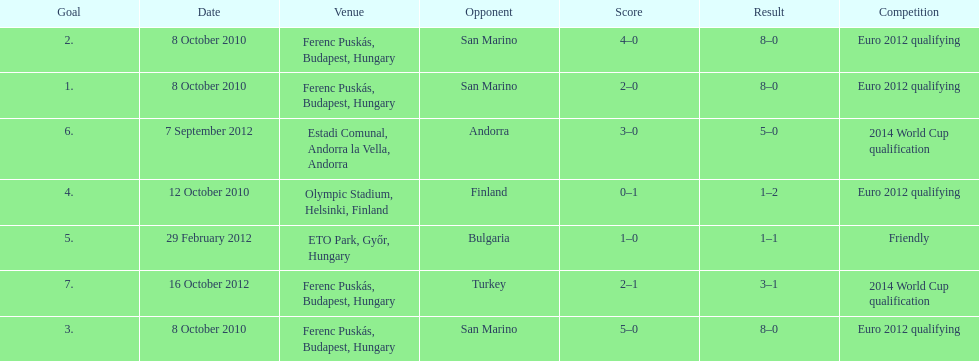How many non-qualifying games did he score in? 1. I'm looking to parse the entire table for insights. Could you assist me with that? {'header': ['Goal', 'Date', 'Venue', 'Opponent', 'Score', 'Result', 'Competition'], 'rows': [['2.', '8 October 2010', 'Ferenc Puskás, Budapest, Hungary', 'San Marino', '4–0', '8–0', 'Euro 2012 qualifying'], ['1.', '8 October 2010', 'Ferenc Puskás, Budapest, Hungary', 'San Marino', '2–0', '8–0', 'Euro 2012 qualifying'], ['6.', '7 September 2012', 'Estadi Comunal, Andorra la Vella, Andorra', 'Andorra', '3–0', '5–0', '2014 World Cup qualification'], ['4.', '12 October 2010', 'Olympic Stadium, Helsinki, Finland', 'Finland', '0–1', '1–2', 'Euro 2012 qualifying'], ['5.', '29 February 2012', 'ETO Park, Győr, Hungary', 'Bulgaria', '1–0', '1–1', 'Friendly'], ['7.', '16 October 2012', 'Ferenc Puskás, Budapest, Hungary', 'Turkey', '2–1', '3–1', '2014 World Cup qualification'], ['3.', '8 October 2010', 'Ferenc Puskás, Budapest, Hungary', 'San Marino', '5–0', '8–0', 'Euro 2012 qualifying']]} 